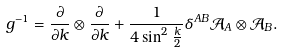Convert formula to latex. <formula><loc_0><loc_0><loc_500><loc_500>g ^ { - 1 } = \frac { \partial } { \partial k } \otimes \frac { \partial } { \partial k } + \frac { 1 } { 4 \sin ^ { 2 } \frac { k } { 2 } } \delta ^ { A B } { \mathcal { A } } _ { A } \otimes { \mathcal { A } } _ { B } .</formula> 